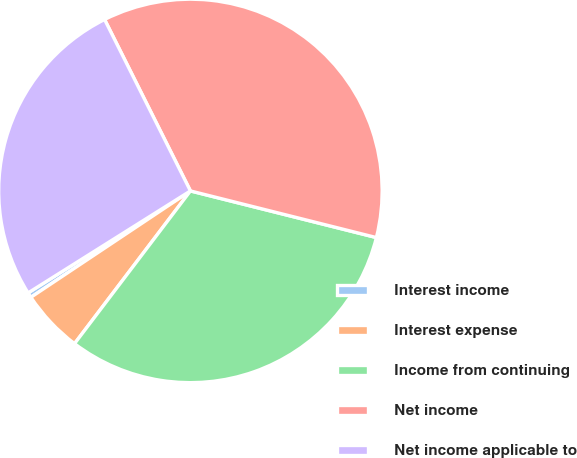<chart> <loc_0><loc_0><loc_500><loc_500><pie_chart><fcel>Interest income<fcel>Interest expense<fcel>Income from continuing<fcel>Net income<fcel>Net income applicable to<nl><fcel>0.43%<fcel>5.31%<fcel>31.42%<fcel>36.3%<fcel>26.54%<nl></chart> 